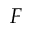<formula> <loc_0><loc_0><loc_500><loc_500>F</formula> 